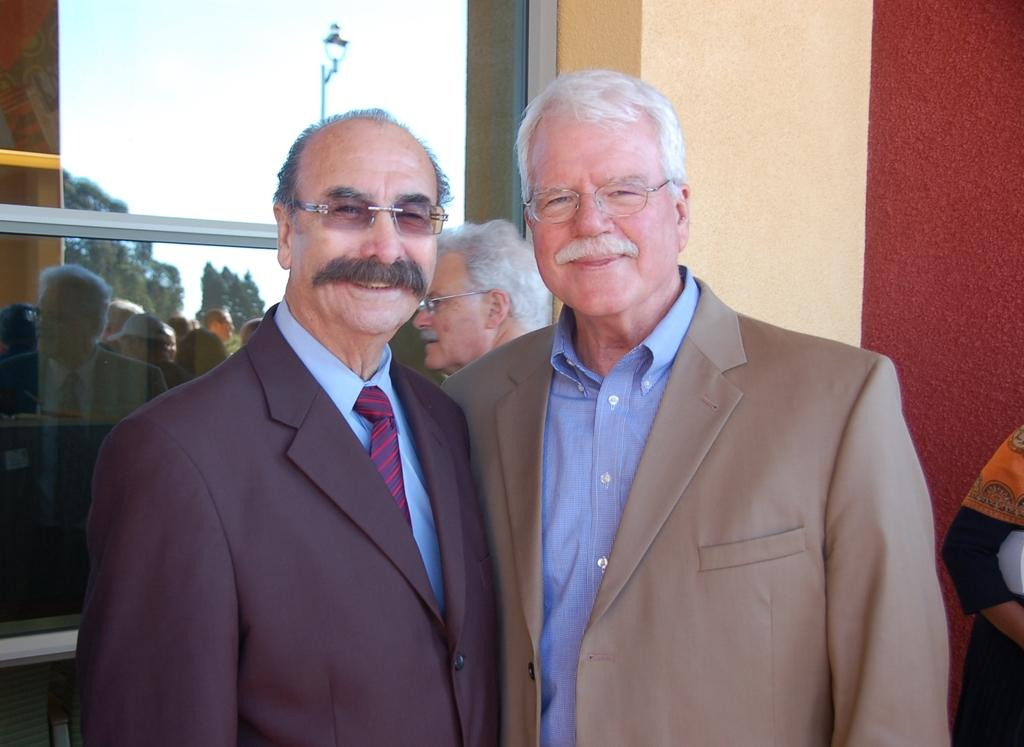What are the people in the image doing? The people in the image are standing and smiling. What can be seen in the background of the image? There is a building and a glass window in the background of the image. How many people are in the background of the image? There are two persons in the background of the image. What type of street is visible in the image? There is no street visible in the image. Who is the creator of the glass window in the background? The creator of the glass window is not mentioned or visible in the image. 